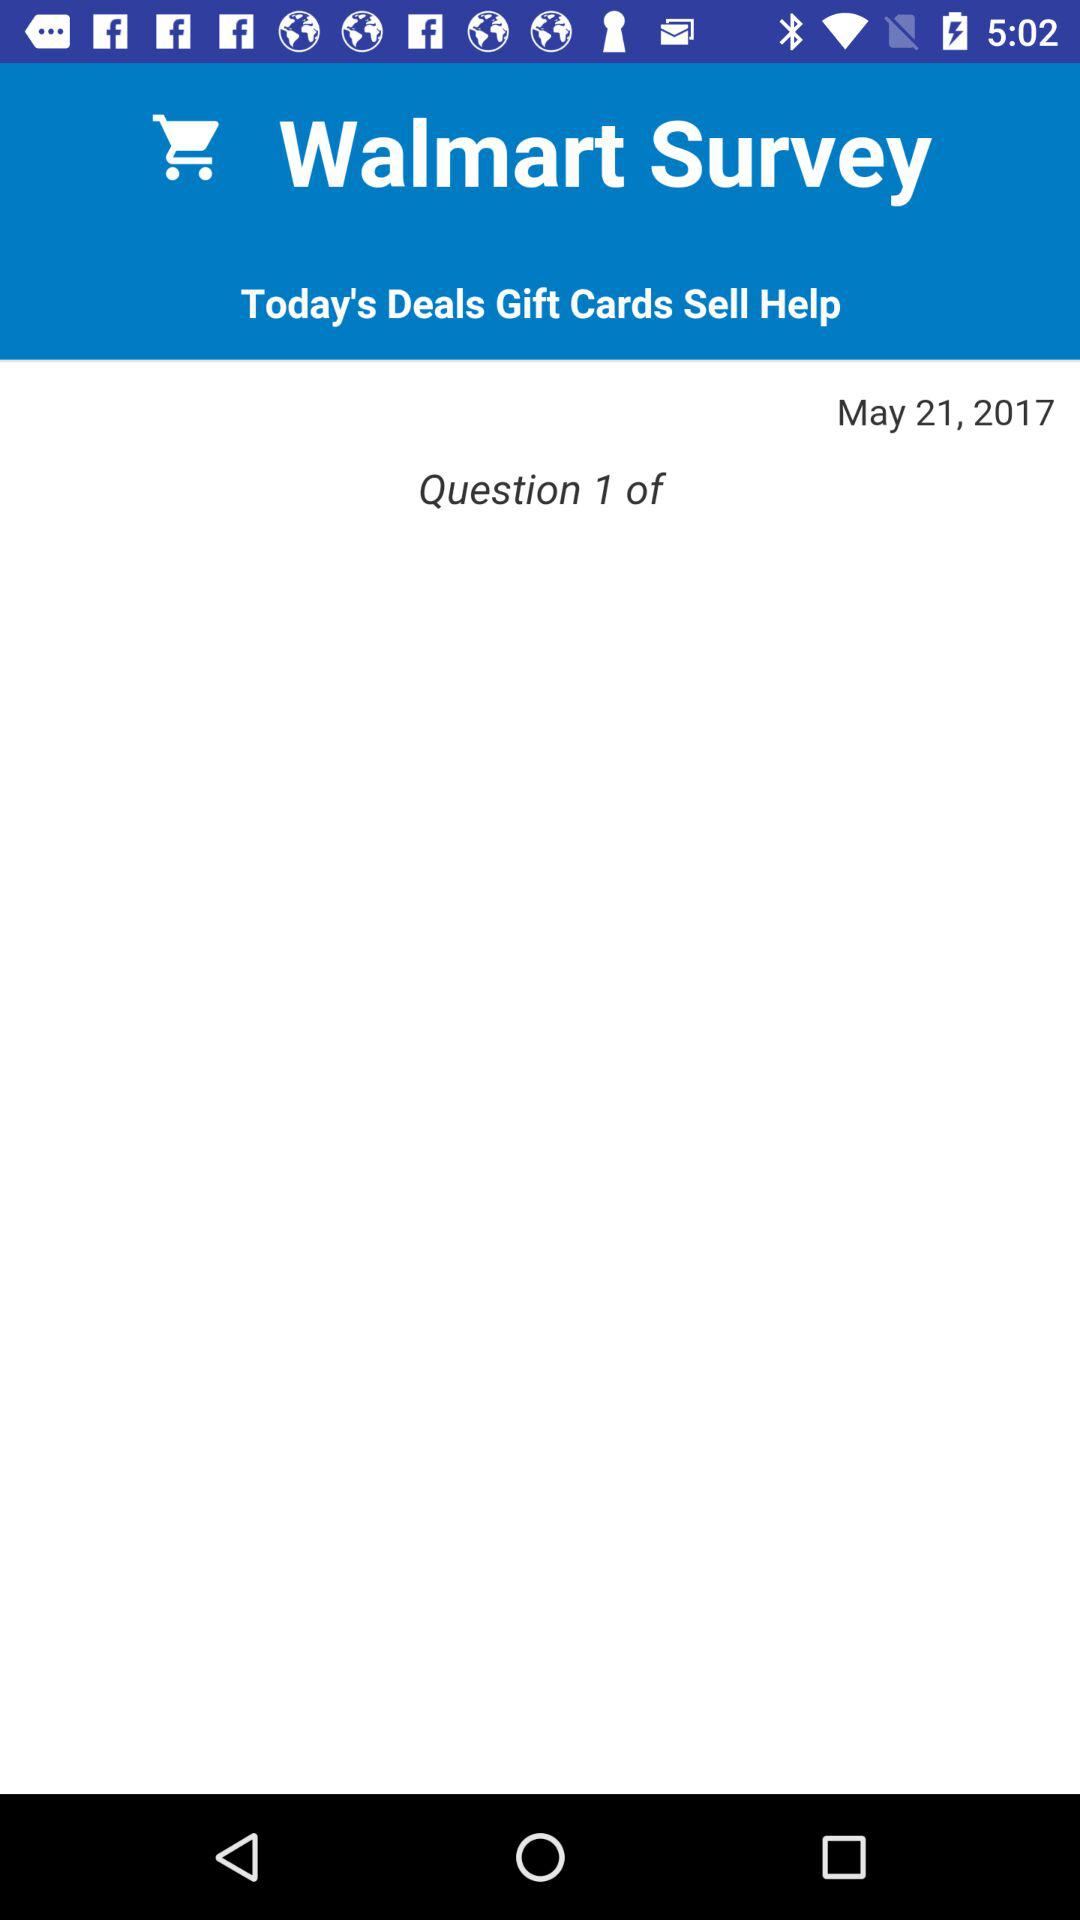What's the date? The date is May 21, 2017. 